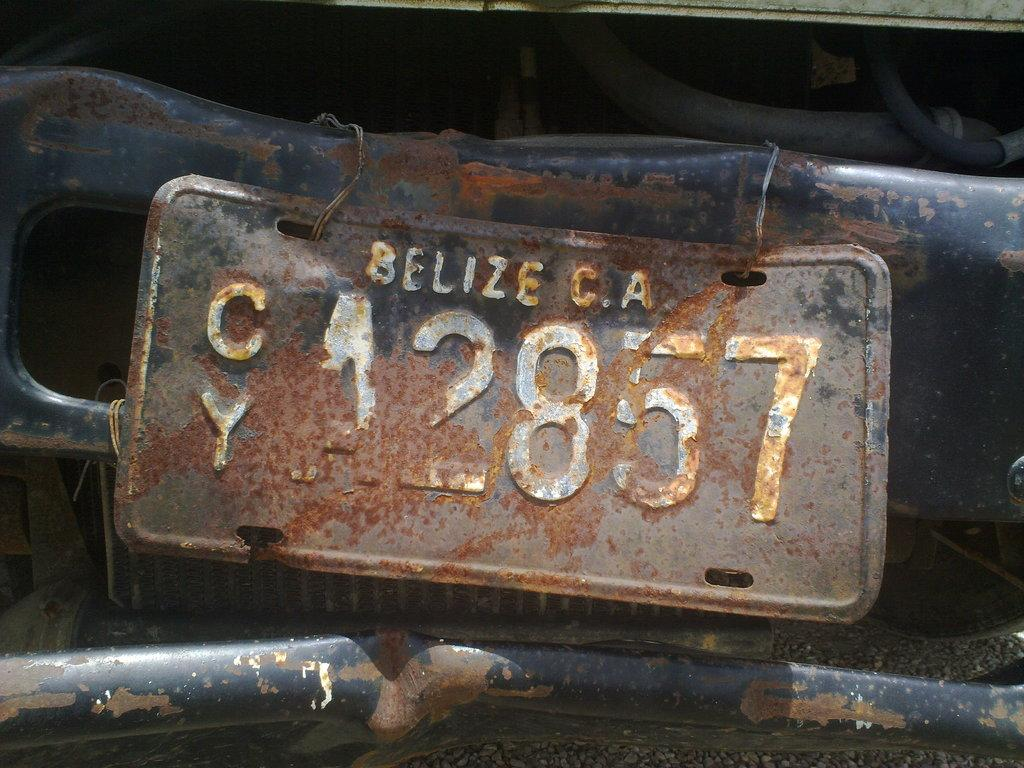What type of object is made of metal in the image? There is a metal object in the image, but the specific type of object is not mentioned. What can be found on the metal object? There is a number plate in the image. What type of zephyr can be seen blowing through the image? There is no mention of a zephyr in the image, as it is a meteorological term for a gentle breeze. Can you tell me the author of the prose in the image? There is no prose or written text present in the image, so it is not possible to determine the author. 